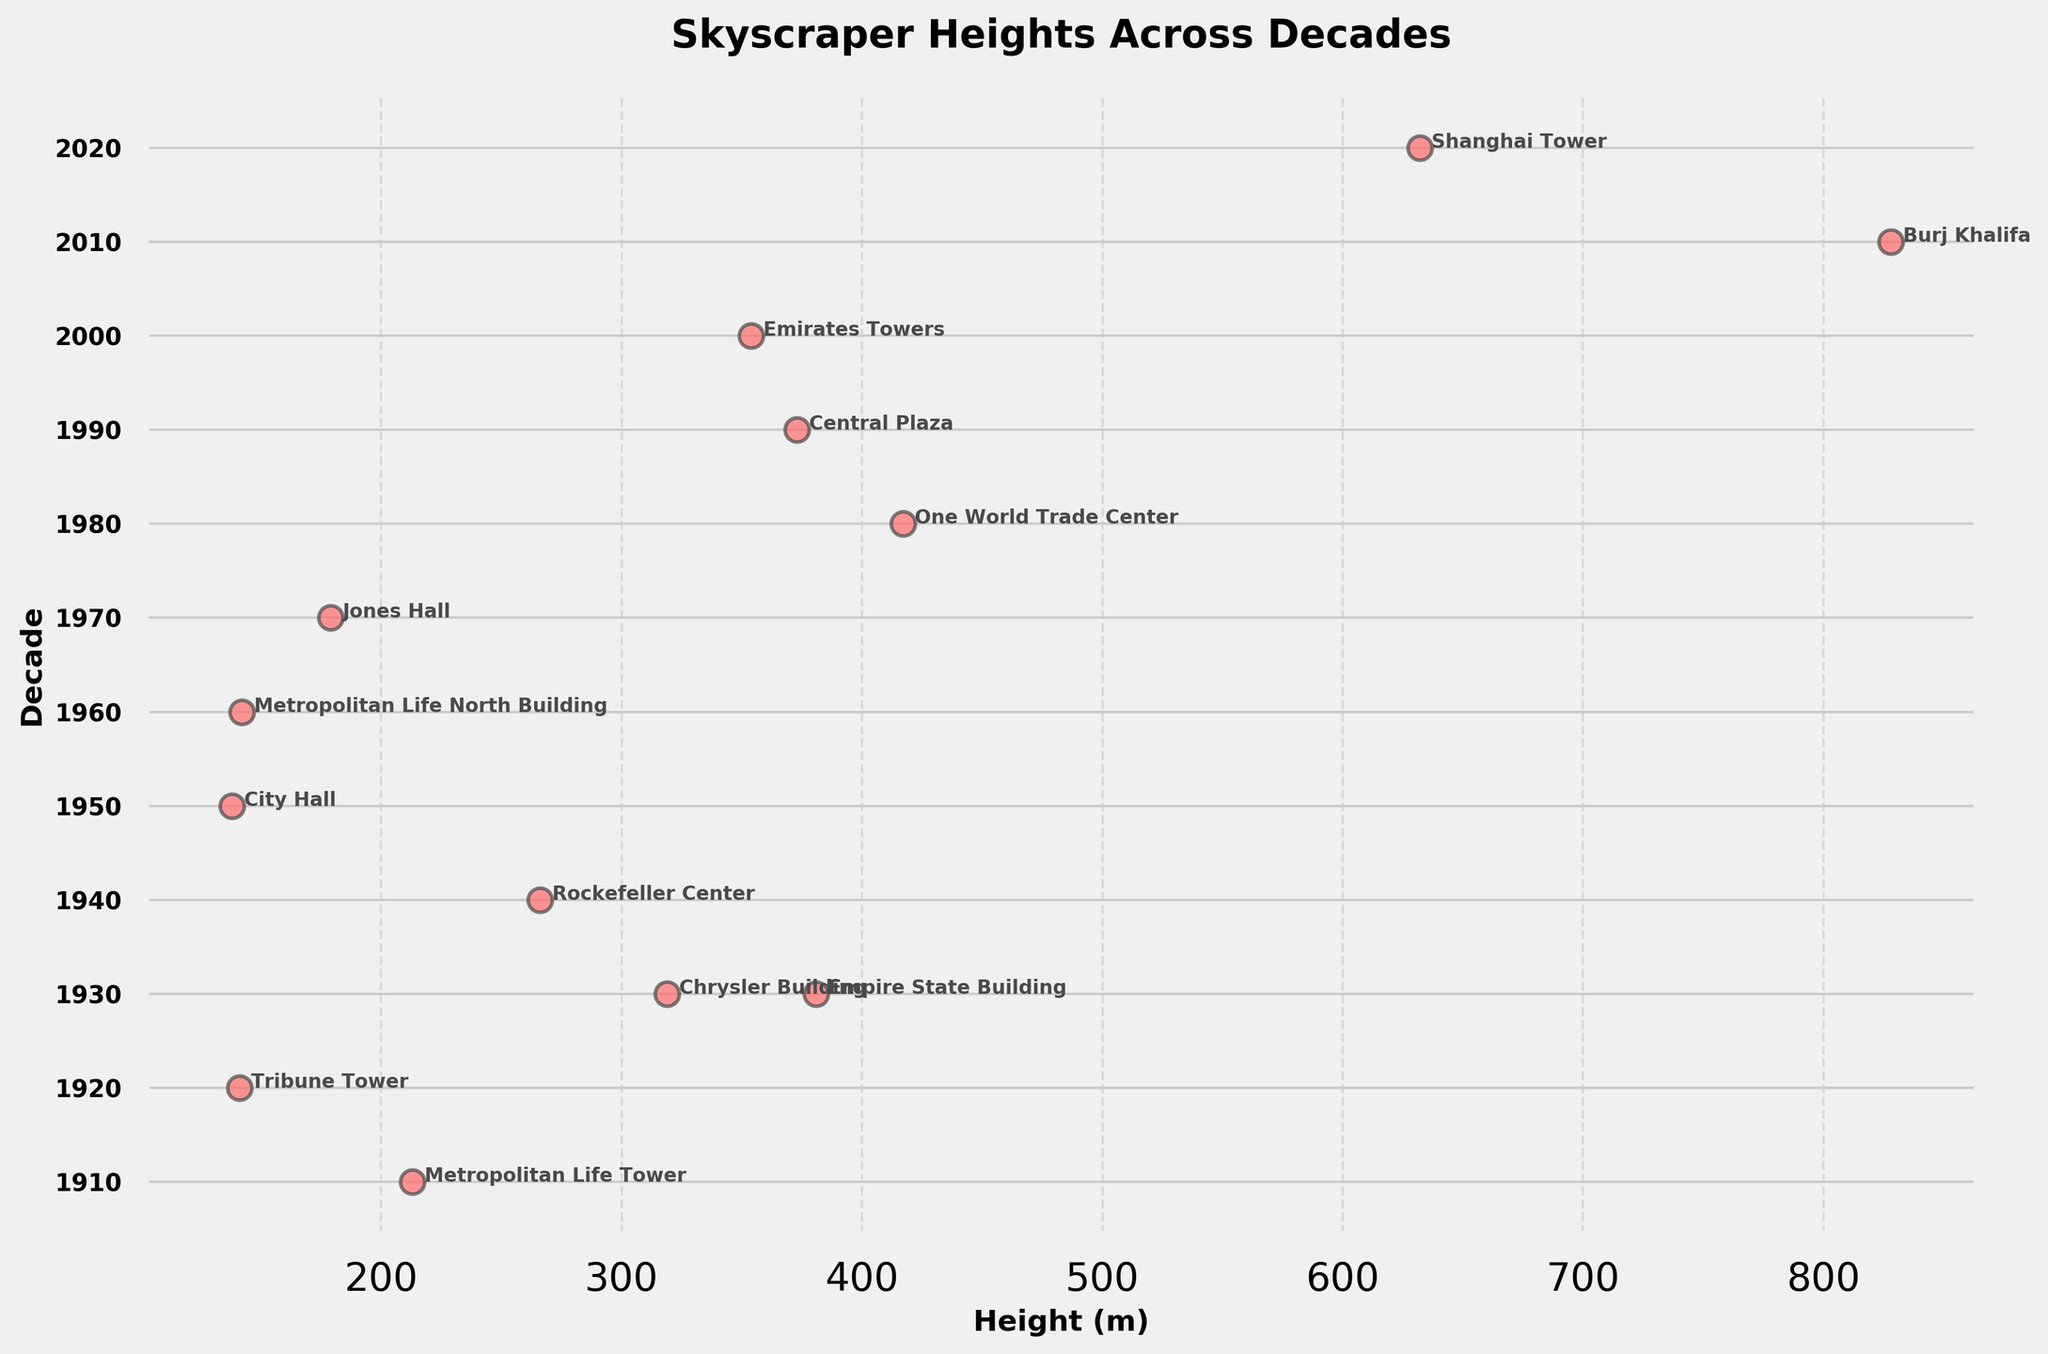What is the title of the plot? The title is usually located at the top of the plot. Here, it is clearly stated as 'Skyscraper Heights Across Decades'.
Answer: Skyscraper Heights Across Decades How many data points are shown for the 1970s? To find this, locate the decade '1970' on the y-axis and count the number of dots aligned horizontally with this tick. There is one dot in the 1970s.
Answer: 1 Which city has the tallest building depicted in the plot, and what is its height? Find the highest point of any dot on the x-axis, which corresponds to the Burj Khalifa in 2010. The height is annotated next to the dot, showing it as 828 meters.
Answer: Dubai, 828 meters How does the median height of buildings in the 1930s compare to that in the 2020s? In the 1930s, we see two buildings: the Chrysler Building (319 m) and the Empire State Building (381 m). The median is the average of these two: (319 + 381) / 2 = 350 m. In 2020, there is only one data point, the Shanghai Tower (632 m), which is also its median. Therefore, 350 m in the 1930s is less than 632 m in the 2020s.
Answer: 1930s: 350 m, 2020s: 632 m Which decade has the highest range of building heights, and what are the minimum and maximum heights? Look for the decade with the widest spread of points on the x-axis. The 1930s have buildings from 319 m to 381 m, giving a range of 62 m. The 2010s, with the Burj Khalifa (828 m), have a greater range. Thus, find the only other height if any beside 828 m. In the 2010s, there’s only 828 m, no range.
Answer: 1930s, 319 m and 381 m In what decade do we see the first skyscraper over 300 meters? By analyzing the plot from left to right, we can see that the first dot surpassing 300 meters appears in the 1930s with the Chrysler Building (319 m) and Empire State Building (381 m).
Answer: 1930s Which city appears most frequently on the plot, and in which decades? Look at the cities annotated near the dots and count their frequency. New York appears in the 1910s, 1930s (twice), 1940s, 1960s, and 1980s, totaling six times.
Answer: New York, multiple decades including 1910s-1980s What is the height difference between the tallest and shortest buildings in the 2000s? The 2000s show the Emirates Towers (354 m) and no other data points. Without another skyscraper for comparison, the height difference is 0 m.
Answer: 0 meters 